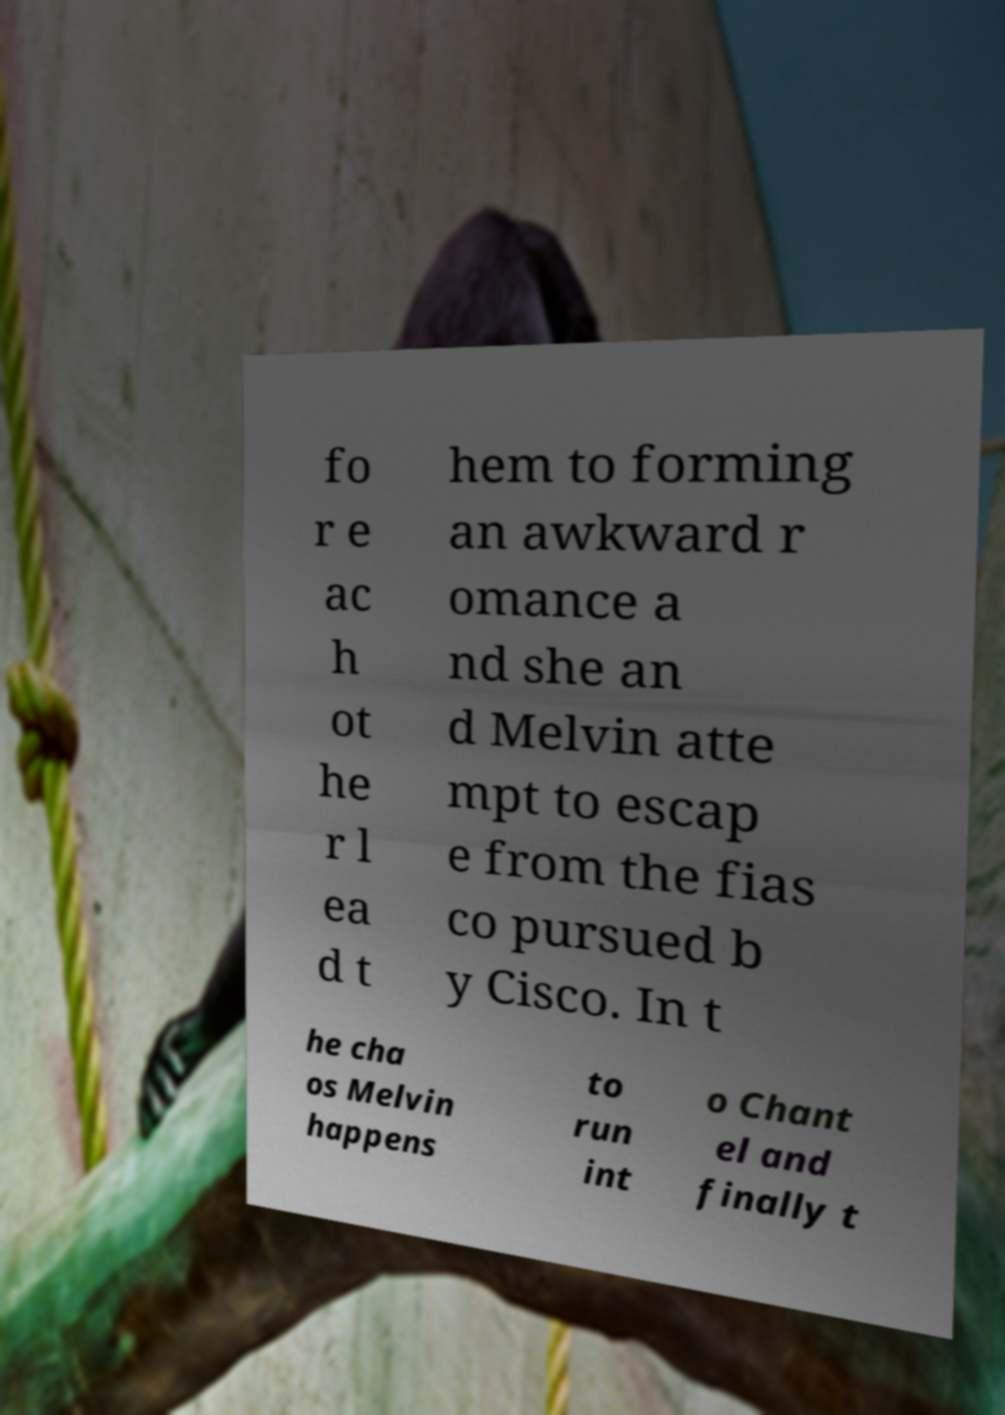Please read and relay the text visible in this image. What does it say? fo r e ac h ot he r l ea d t hem to forming an awkward r omance a nd she an d Melvin atte mpt to escap e from the fias co pursued b y Cisco. In t he cha os Melvin happens to run int o Chant el and finally t 